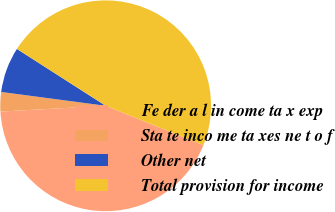Convert chart to OTSL. <chart><loc_0><loc_0><loc_500><loc_500><pie_chart><fcel>Fe der a l in come ta x exp<fcel>Sta te inco me ta xes ne t o f<fcel>Other net<fcel>Total provision for income<nl><fcel>43.03%<fcel>2.97%<fcel>6.97%<fcel>47.03%<nl></chart> 